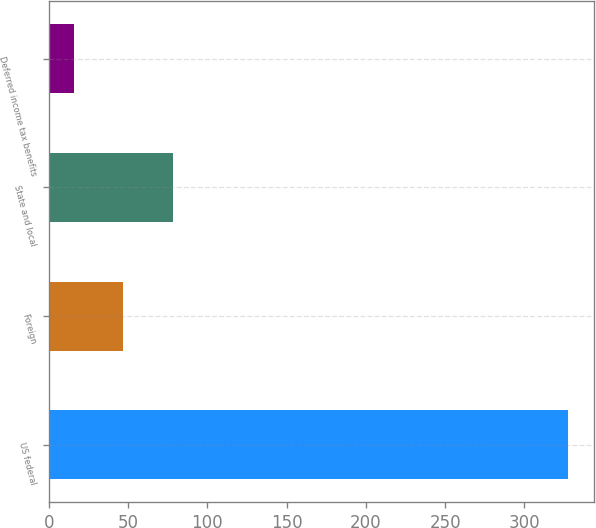<chart> <loc_0><loc_0><loc_500><loc_500><bar_chart><fcel>US federal<fcel>Foreign<fcel>State and local<fcel>Deferred income tax benefits<nl><fcel>327.7<fcel>46.9<fcel>78.1<fcel>15.7<nl></chart> 